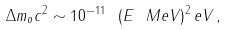<formula> <loc_0><loc_0><loc_500><loc_500>\Delta m _ { o } c ^ { 2 } \sim 1 0 ^ { - 1 1 } \ ( E \ M e V ) ^ { 2 } \, e V \, ,</formula> 